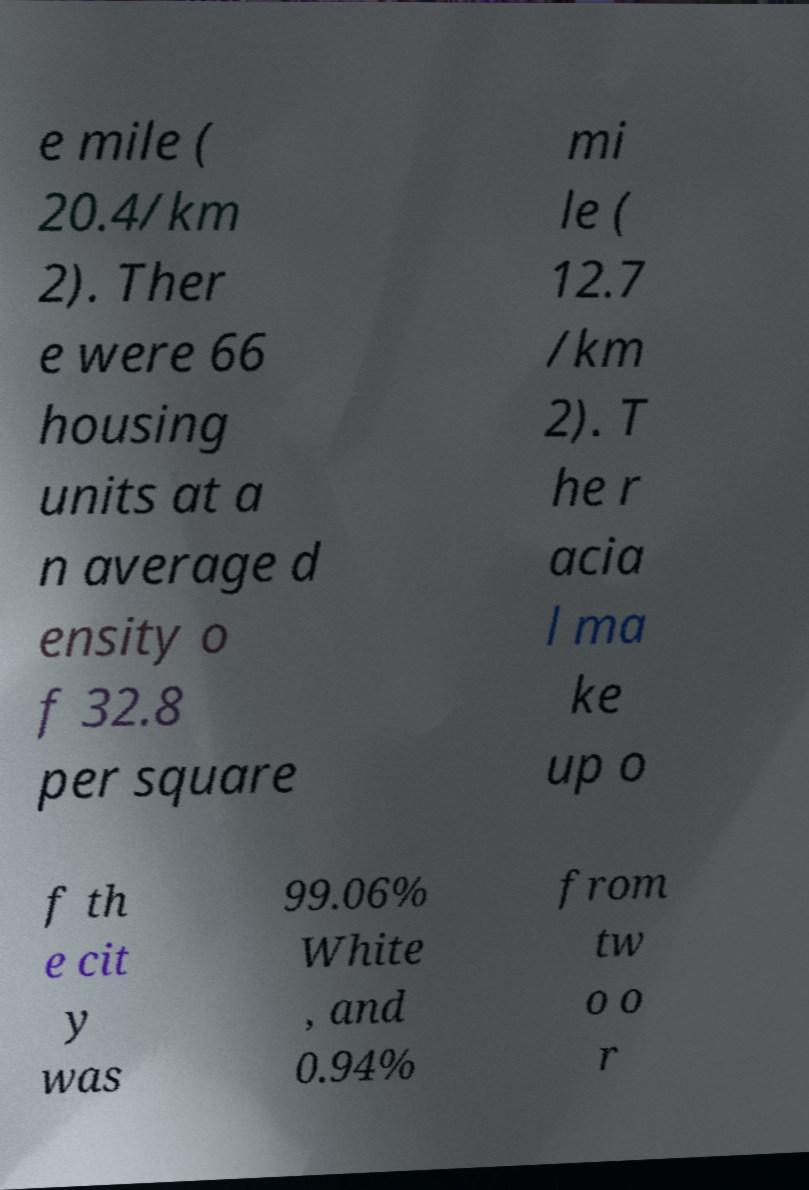I need the written content from this picture converted into text. Can you do that? e mile ( 20.4/km 2). Ther e were 66 housing units at a n average d ensity o f 32.8 per square mi le ( 12.7 /km 2). T he r acia l ma ke up o f th e cit y was 99.06% White , and 0.94% from tw o o r 